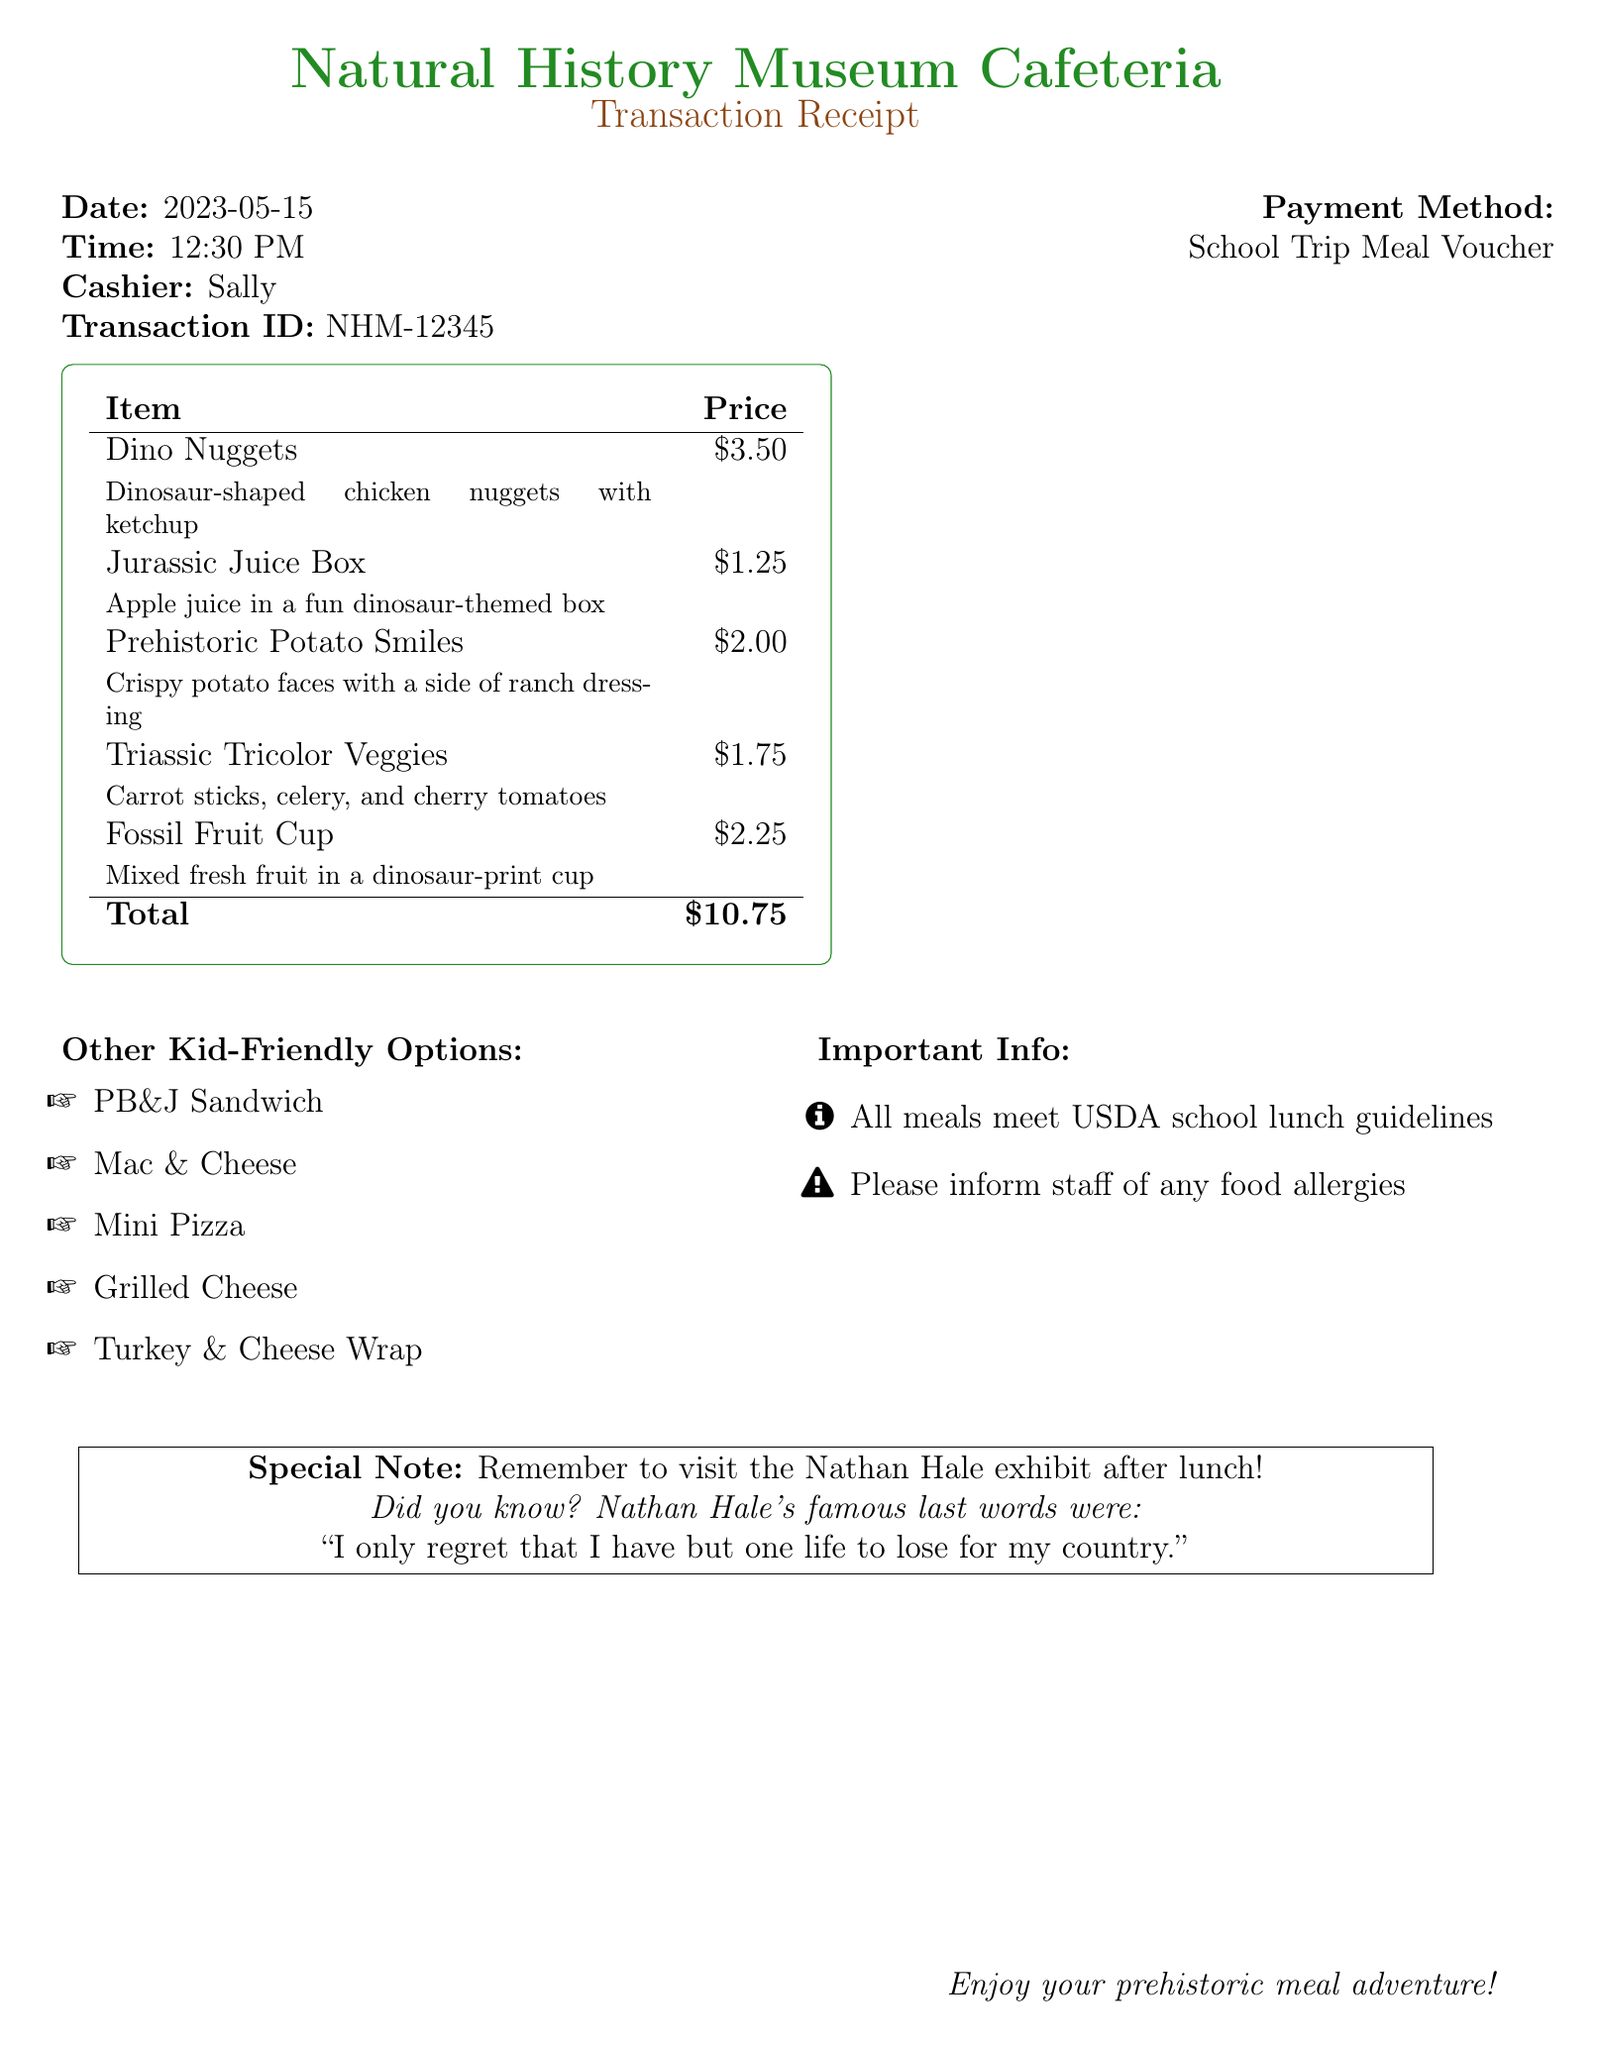What is the restaurant name? The restaurant name is specified at the beginning of the receipt.
Answer: Natural History Museum Cafeteria What time was the transaction made? The transaction time is mentioned in the details section.
Answer: 12:30 PM Who was the cashier? The cashier's name is provided on the receipt for identification.
Answer: Sally What is the total amount spent? The total amount is calculated from the item prices listed.
Answer: $10.75 What kid-friendly meal option is priced at $1.25? This requires recalling the specific items and their prices from the itemized list.
Answer: Jurassic Juice Box What is a special note mentioned on the receipt? A specific note is highlighted to draw attention to a museum exhibit.
Answer: Remember to visit the Nathan Hale exhibit after lunch! How many itemized meal options are listed? Counting the items in the item list provides the answer.
Answer: Five What is the allergen warning? The receipt includes a reminder about allergens that needs to be communicated.
Answer: Please inform staff of any food allergies What is the payment method? The payment method is stated clearly in the transaction details.
Answer: School Trip Meal Voucher 